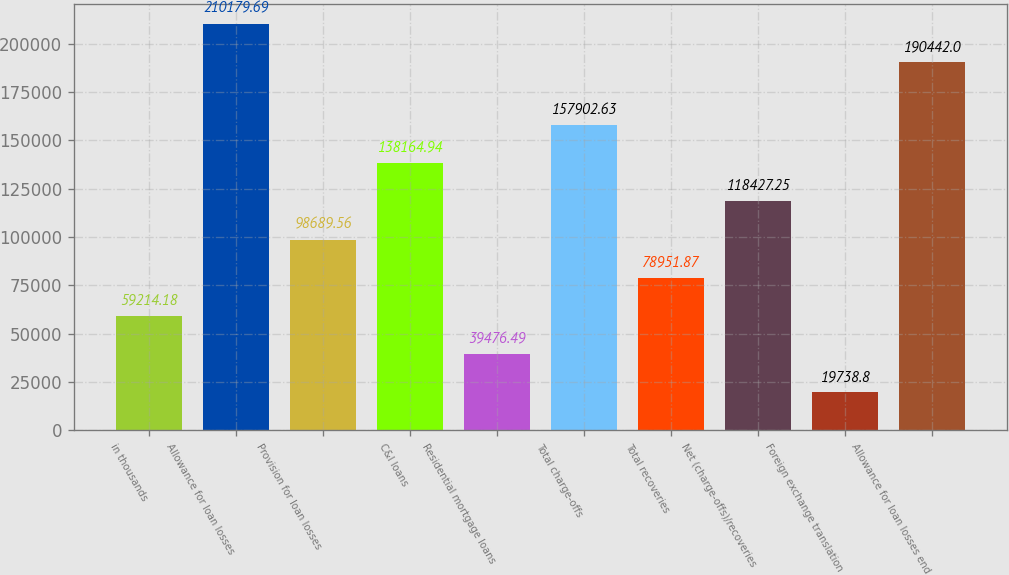<chart> <loc_0><loc_0><loc_500><loc_500><bar_chart><fcel>in thousands<fcel>Allowance for loan losses<fcel>Provision for loan losses<fcel>C&I loans<fcel>Residential mortgage loans<fcel>Total charge-offs<fcel>Total recoveries<fcel>Net (charge-offs)/recoveries<fcel>Foreign exchange translation<fcel>Allowance for loan losses end<nl><fcel>59214.2<fcel>210180<fcel>98689.6<fcel>138165<fcel>39476.5<fcel>157903<fcel>78951.9<fcel>118427<fcel>19738.8<fcel>190442<nl></chart> 